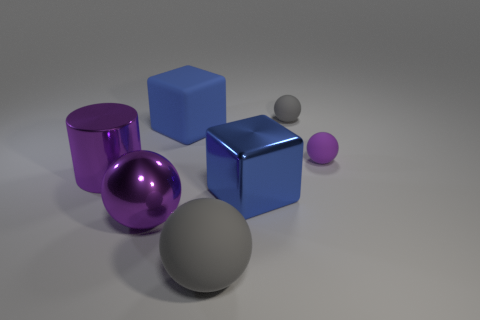Subtract all gray spheres. How many were subtracted if there are1gray spheres left? 1 Subtract 1 balls. How many balls are left? 3 Subtract all green balls. Subtract all gray blocks. How many balls are left? 4 Add 2 blue spheres. How many objects exist? 9 Subtract all cylinders. How many objects are left? 6 Add 3 big balls. How many big balls are left? 5 Add 2 blue shiny things. How many blue shiny things exist? 3 Subtract 0 red cubes. How many objects are left? 7 Subtract all small green objects. Subtract all tiny rubber balls. How many objects are left? 5 